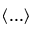Convert formula to latex. <formula><loc_0><loc_0><loc_500><loc_500>\left < \dots \right ></formula> 